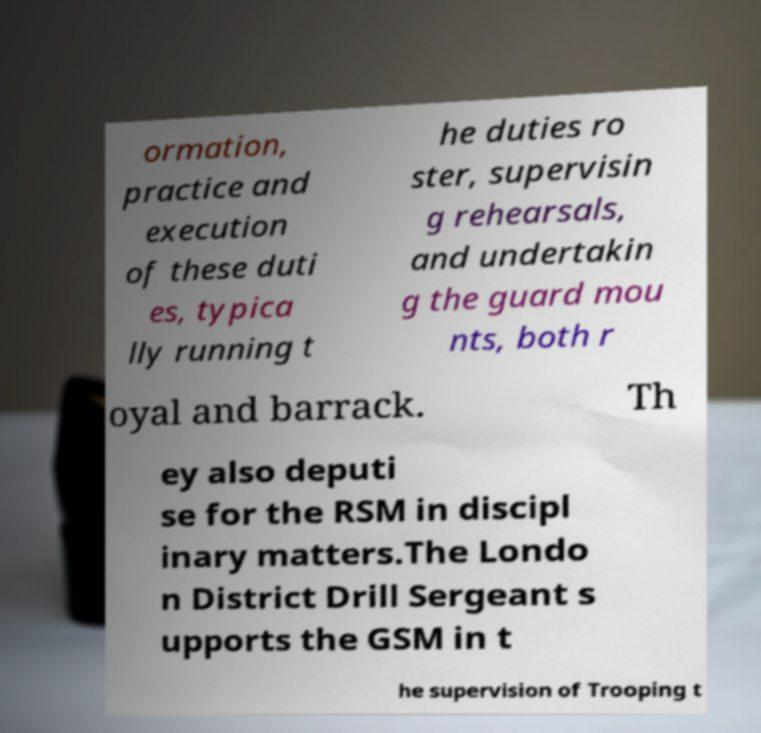For documentation purposes, I need the text within this image transcribed. Could you provide that? ormation, practice and execution of these duti es, typica lly running t he duties ro ster, supervisin g rehearsals, and undertakin g the guard mou nts, both r oyal and barrack. Th ey also deputi se for the RSM in discipl inary matters.The Londo n District Drill Sergeant s upports the GSM in t he supervision of Trooping t 